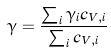<formula> <loc_0><loc_0><loc_500><loc_500>\gamma = \frac { \sum _ { i } \gamma _ { i } c _ { V , i } } { \sum _ { i } c _ { V , i } }</formula> 